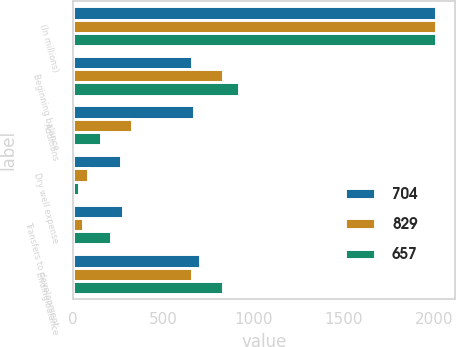<chart> <loc_0><loc_0><loc_500><loc_500><stacked_bar_chart><ecel><fcel>(In millions)<fcel>Beginning balance<fcel>Additions<fcel>Dry well expense<fcel>Transfers to development<fcel>Ending balance<nl><fcel>704<fcel>2011<fcel>657<fcel>670<fcel>268<fcel>279<fcel>704<nl><fcel>829<fcel>2010<fcel>829<fcel>329<fcel>83<fcel>54<fcel>657<nl><fcel>657<fcel>2009<fcel>917<fcel>155<fcel>32<fcel>211<fcel>829<nl></chart> 